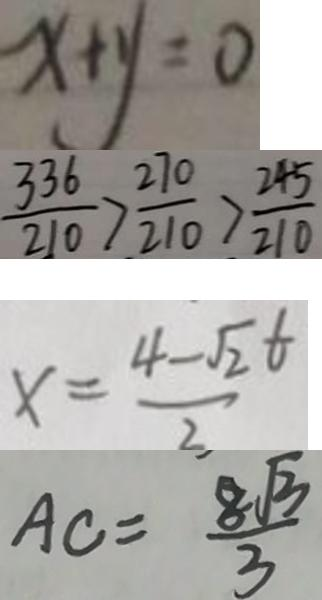<formula> <loc_0><loc_0><loc_500><loc_500>x + y = 0 
 \frac { 3 3 6 } { 2 1 0 } > \frac { 2 7 0 } { 2 1 0 } > \frac { 2 4 5 } { 2 1 0 } 
 x = \frac { 4 - \sqrt { 2 } t } { 2 } 
 A C = \frac { 8 \sqrt { 3 } } { 3 }</formula> 